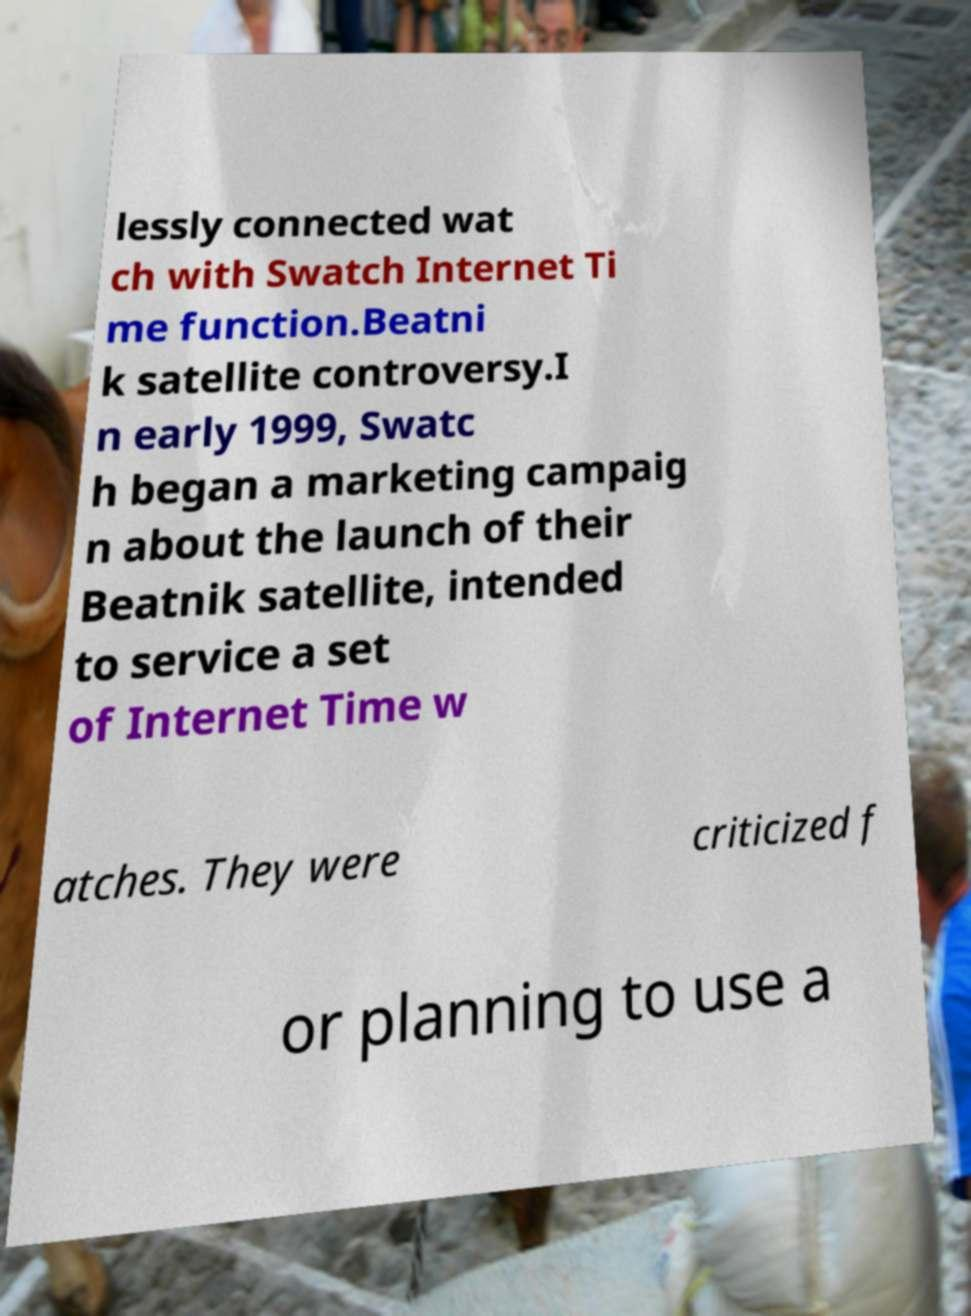There's text embedded in this image that I need extracted. Can you transcribe it verbatim? lessly connected wat ch with Swatch Internet Ti me function.Beatni k satellite controversy.I n early 1999, Swatc h began a marketing campaig n about the launch of their Beatnik satellite, intended to service a set of Internet Time w atches. They were criticized f or planning to use a 